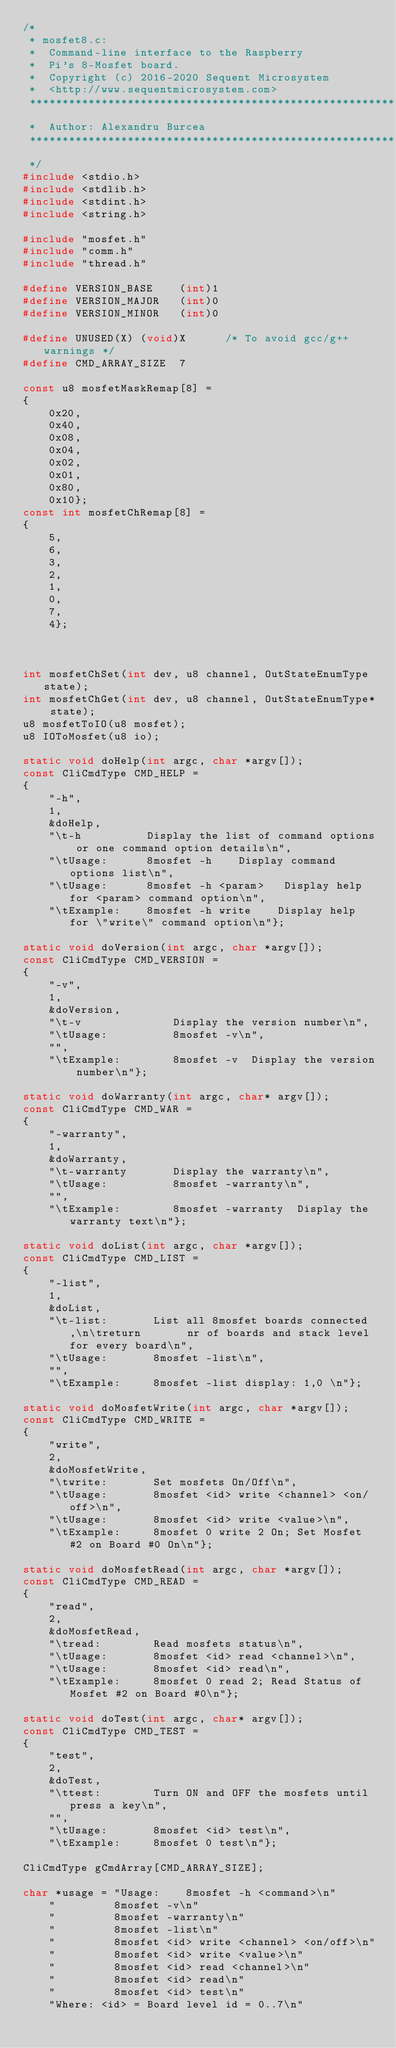<code> <loc_0><loc_0><loc_500><loc_500><_C_>/*
 * mosfet8.c:
 *	Command-line interface to the Raspberry
 *	Pi's 8-Mosfet board.
 *	Copyright (c) 2016-2020 Sequent Microsystem
 *	<http://www.sequentmicrosystem.com>
 ***********************************************************************
 *	Author: Alexandru Burcea
 ***********************************************************************
 */
#include <stdio.h>
#include <stdlib.h>
#include <stdint.h>
#include <string.h>

#include "mosfet.h"
#include "comm.h"
#include "thread.h"

#define VERSION_BASE	(int)1
#define VERSION_MAJOR	(int)0
#define VERSION_MINOR	(int)0

#define UNUSED(X) (void)X      /* To avoid gcc/g++ warnings */
#define CMD_ARRAY_SIZE	7

const u8 mosfetMaskRemap[8] =
{
	0x20,
	0x40,
	0x08,
	0x04,
	0x02,
	0x01,
	0x80,
	0x10};
const int mosfetChRemap[8] =
{
	5,
	6,
	3,
	2,
	1,
	0,
	7,
	4};



int mosfetChSet(int dev, u8 channel, OutStateEnumType state);
int mosfetChGet(int dev, u8 channel, OutStateEnumType* state);
u8 mosfetToIO(u8 mosfet);
u8 IOToMosfet(u8 io);

static void doHelp(int argc, char *argv[]);
const CliCmdType CMD_HELP =
{
	"-h",
	1,
	&doHelp,
	"\t-h          Display the list of command options or one command option details\n",
	"\tUsage:      8mosfet -h    Display command options list\n",
	"\tUsage:      8mosfet -h <param>   Display help for <param> command option\n",
	"\tExample:    8mosfet -h write    Display help for \"write\" command option\n"};

static void doVersion(int argc, char *argv[]);
const CliCmdType CMD_VERSION =
{
	"-v",
	1,
	&doVersion,
	"\t-v              Display the version number\n",
	"\tUsage:          8mosfet -v\n",
	"",
	"\tExample:        8mosfet -v  Display the version number\n"};

static void doWarranty(int argc, char* argv[]);
const CliCmdType CMD_WAR =
{
	"-warranty",
	1,
	&doWarranty,
	"\t-warranty       Display the warranty\n",
	"\tUsage:          8mosfet -warranty\n",
	"",
	"\tExample:        8mosfet -warranty  Display the warranty text\n"};

static void doList(int argc, char *argv[]);
const CliCmdType CMD_LIST =
{
	"-list",
	1,
	&doList,
	"\t-list:       List all 8mosfet boards connected,\n\treturn       nr of boards and stack level for every board\n",
	"\tUsage:       8mosfet -list\n",
	"",
	"\tExample:     8mosfet -list display: 1,0 \n"};

static void doMosfetWrite(int argc, char *argv[]);
const CliCmdType CMD_WRITE =
{
	"write",
	2,
	&doMosfetWrite,
	"\twrite:       Set mosfets On/Off\n",
	"\tUsage:       8mosfet <id> write <channel> <on/off>\n",
	"\tUsage:       8mosfet <id> write <value>\n",
	"\tExample:     8mosfet 0 write 2 On; Set Mosfet #2 on Board #0 On\n"};

static void doMosfetRead(int argc, char *argv[]);
const CliCmdType CMD_READ =
{
	"read",
	2,
	&doMosfetRead,
	"\tread:        Read mosfets status\n",
	"\tUsage:       8mosfet <id> read <channel>\n",
	"\tUsage:       8mosfet <id> read\n",
	"\tExample:     8mosfet 0 read 2; Read Status of Mosfet #2 on Board #0\n"};

static void doTest(int argc, char* argv[]);
const CliCmdType CMD_TEST =
{
	"test",
	2,
	&doTest,
	"\ttest:        Turn ON and OFF the mosfets until press a key\n",
	"",
	"\tUsage:       8mosfet <id> test\n",
	"\tExample:     8mosfet 0 test\n"};

CliCmdType gCmdArray[CMD_ARRAY_SIZE];

char *usage = "Usage:	 8mosfet -h <command>\n"
	"         8mosfet -v\n"
	"         8mosfet -warranty\n"
	"         8mosfet -list\n"
	"         8mosfet <id> write <channel> <on/off>\n"
	"         8mosfet <id> write <value>\n"
	"         8mosfet <id> read <channel>\n"
	"         8mosfet <id> read\n"
	"         8mosfet <id> test\n"
	"Where: <id> = Board level id = 0..7\n"</code> 